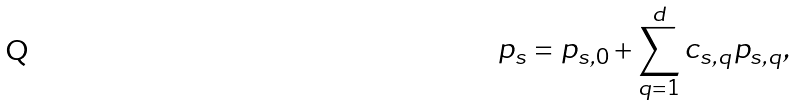<formula> <loc_0><loc_0><loc_500><loc_500>p _ { s } = p _ { s , 0 } + \sum _ { q = 1 } ^ { d } c _ { s , q } p _ { s , q } ,</formula> 